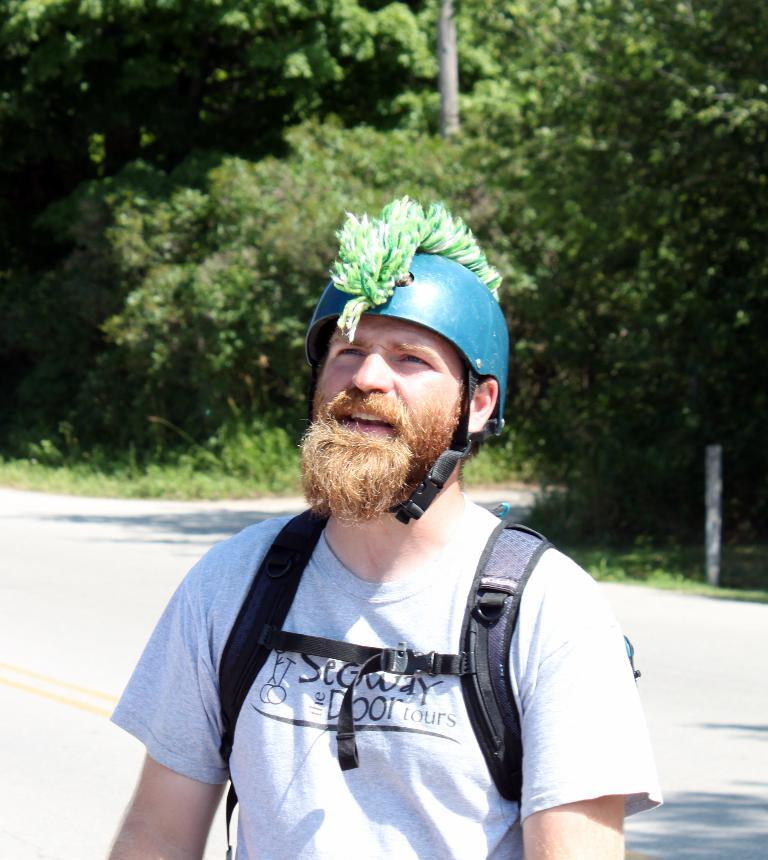Who is present in the image? There is a man in the image. What is the man wearing on his head? The man is wearing a helmet. What is the man carrying in the image? The man is carrying a bag. What can be seen in the background of the image? There is a road, poles, and trees in the background of the image. What type of wrench is the man using to fix the behavior of the ticket in the image? There is no wrench, behavior, or ticket present in the image. 